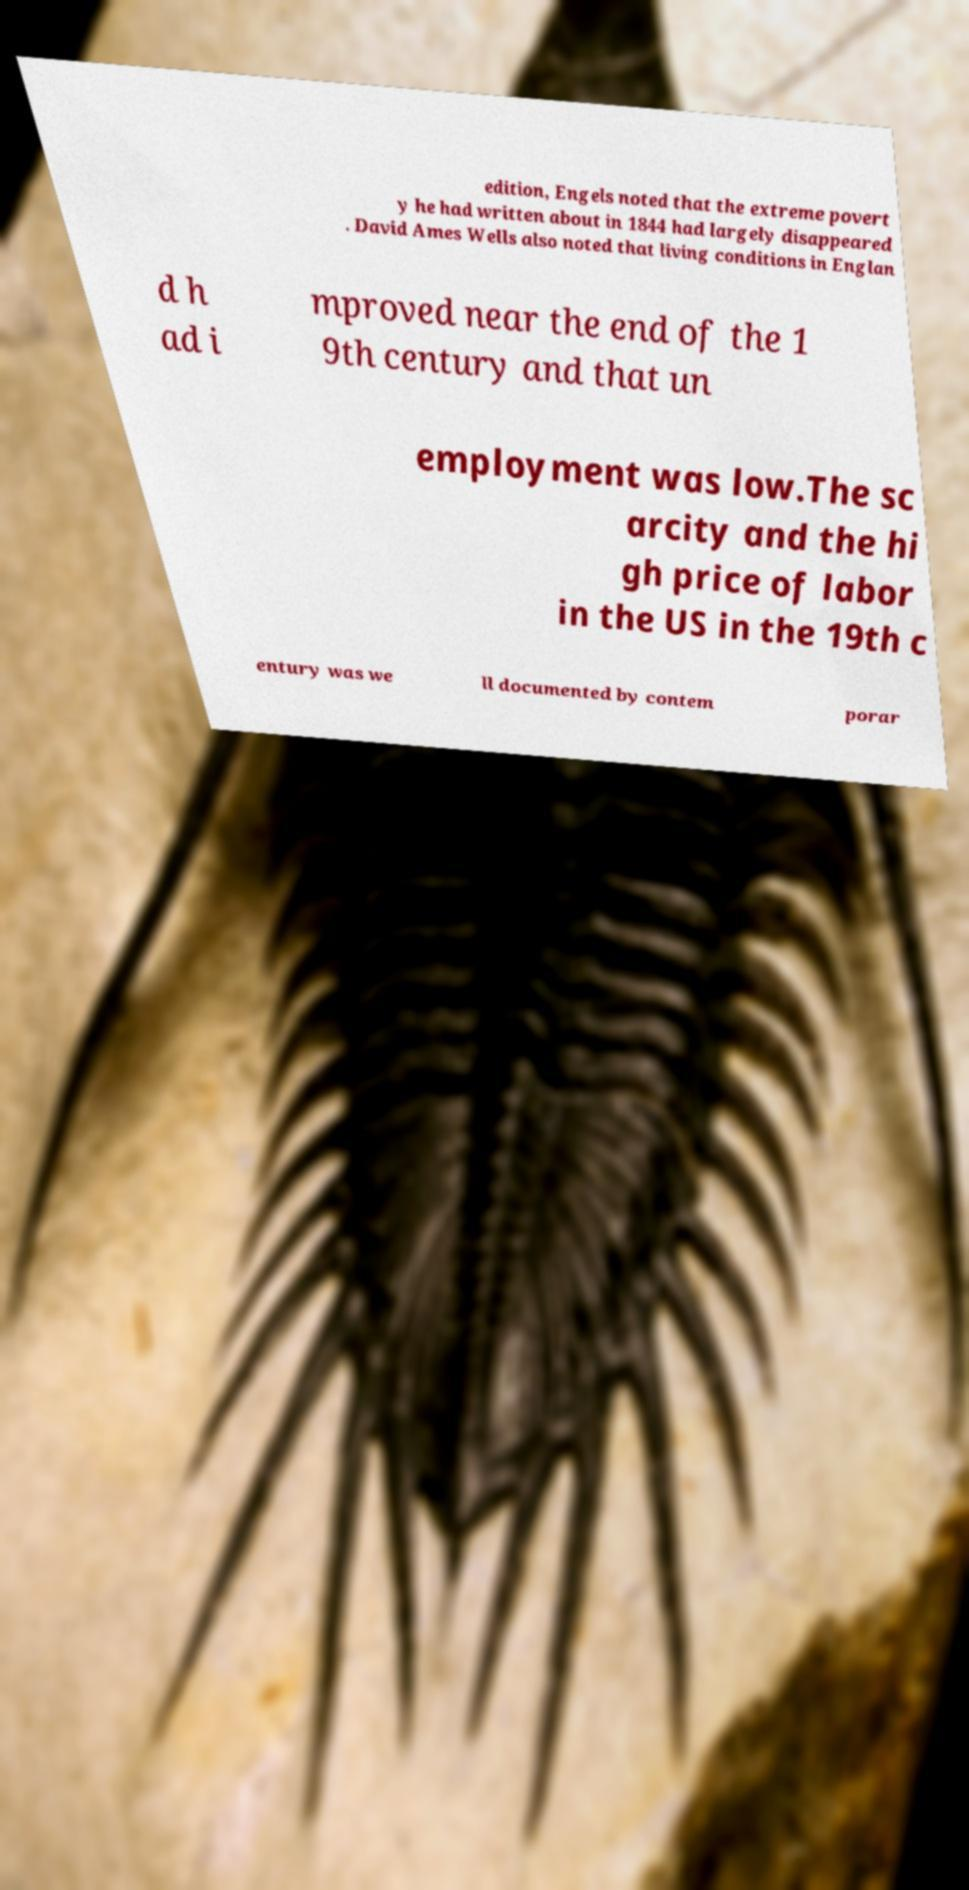Could you extract and type out the text from this image? edition, Engels noted that the extreme povert y he had written about in 1844 had largely disappeared . David Ames Wells also noted that living conditions in Englan d h ad i mproved near the end of the 1 9th century and that un employment was low.The sc arcity and the hi gh price of labor in the US in the 19th c entury was we ll documented by contem porar 